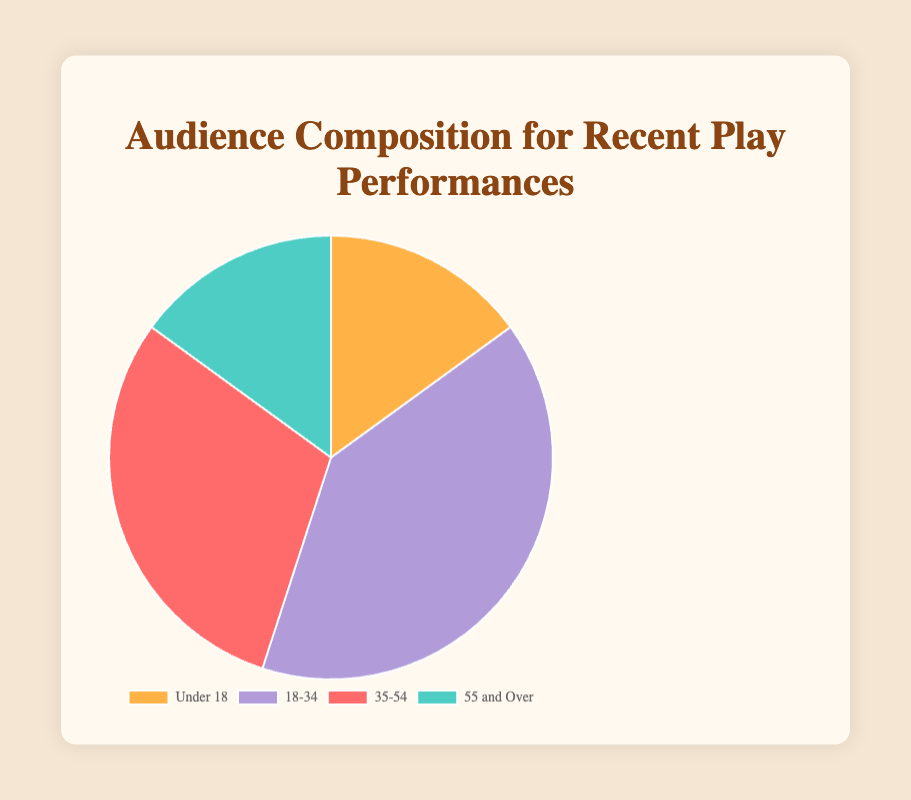What age group has the highest percentage of the audience? Look at the pie chart and identify the age group segment with the largest size. The 18-34 age group has the largest segment with 40%.
Answer: 18-34 Which two age groups have the same percentage of the audience? By examining the chart, we can see that the 'Under 18' and '55 and Over' age groups have equal-sized segments, both at 15%.
Answer: Under 18 and 55 and Over What is the combined percentage of the audience that is either under 18 or 55 and over? Sum the percentages of the 'Under 18' (15%) and '55 and Over' (15%) age groups. Adding these two gives us 15% + 15% = 30%.
Answer: 30% How much larger is the percentage of the 18-34 age group compared to the 35-54 age group? Subtract the percentage of the 35-54 age group (30%) from the percentage of the 18-34 age group (40%). The difference is 40% - 30% = 10%.
Answer: 10% What is the average percentage of the audience composition across all age groups? Sum the percentages of all age groups: 15% + 40% + 30% + 15% = 100%. Then, divide by the number of age groups (4). The average is 100% / 4 = 25%.
Answer: 25% Which age group is represented by the green color in the chart? The chart's legend or the segment itself shows the green color representing the '55 and Over' age group.
Answer: 55 and Over How does the percentage of the 18-34 age group compare to the sum of the percentages of the 'Under 18' and '55 and Over' age groups? The 18-34 age group has 40%. The sum of 'Under 18' and '55 and Over' is 15% + 15% = 30%. Comparing 40% and 30% shows that 40% > 30%.
Answer: 18-34 is greater What percentage of the audience is above 35 years old? Sum the percentages of the '35-54' and '55 and Over' age groups, which is 30% + 15% = 45%.
Answer: 45% What is the difference in the audience percentage between the 'Under 18' and '35-54' age groups? Subtract the percentage of the 'Under 18' age group (15%) from the '35-54' age group (30%). The difference is 30% - 15% = 15%.
Answer: 15% 